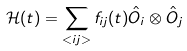Convert formula to latex. <formula><loc_0><loc_0><loc_500><loc_500>\mathcal { H } ( t ) = \sum _ { < i j > } f _ { i j } ( t ) \hat { O } _ { i } \otimes \hat { O } _ { j }</formula> 